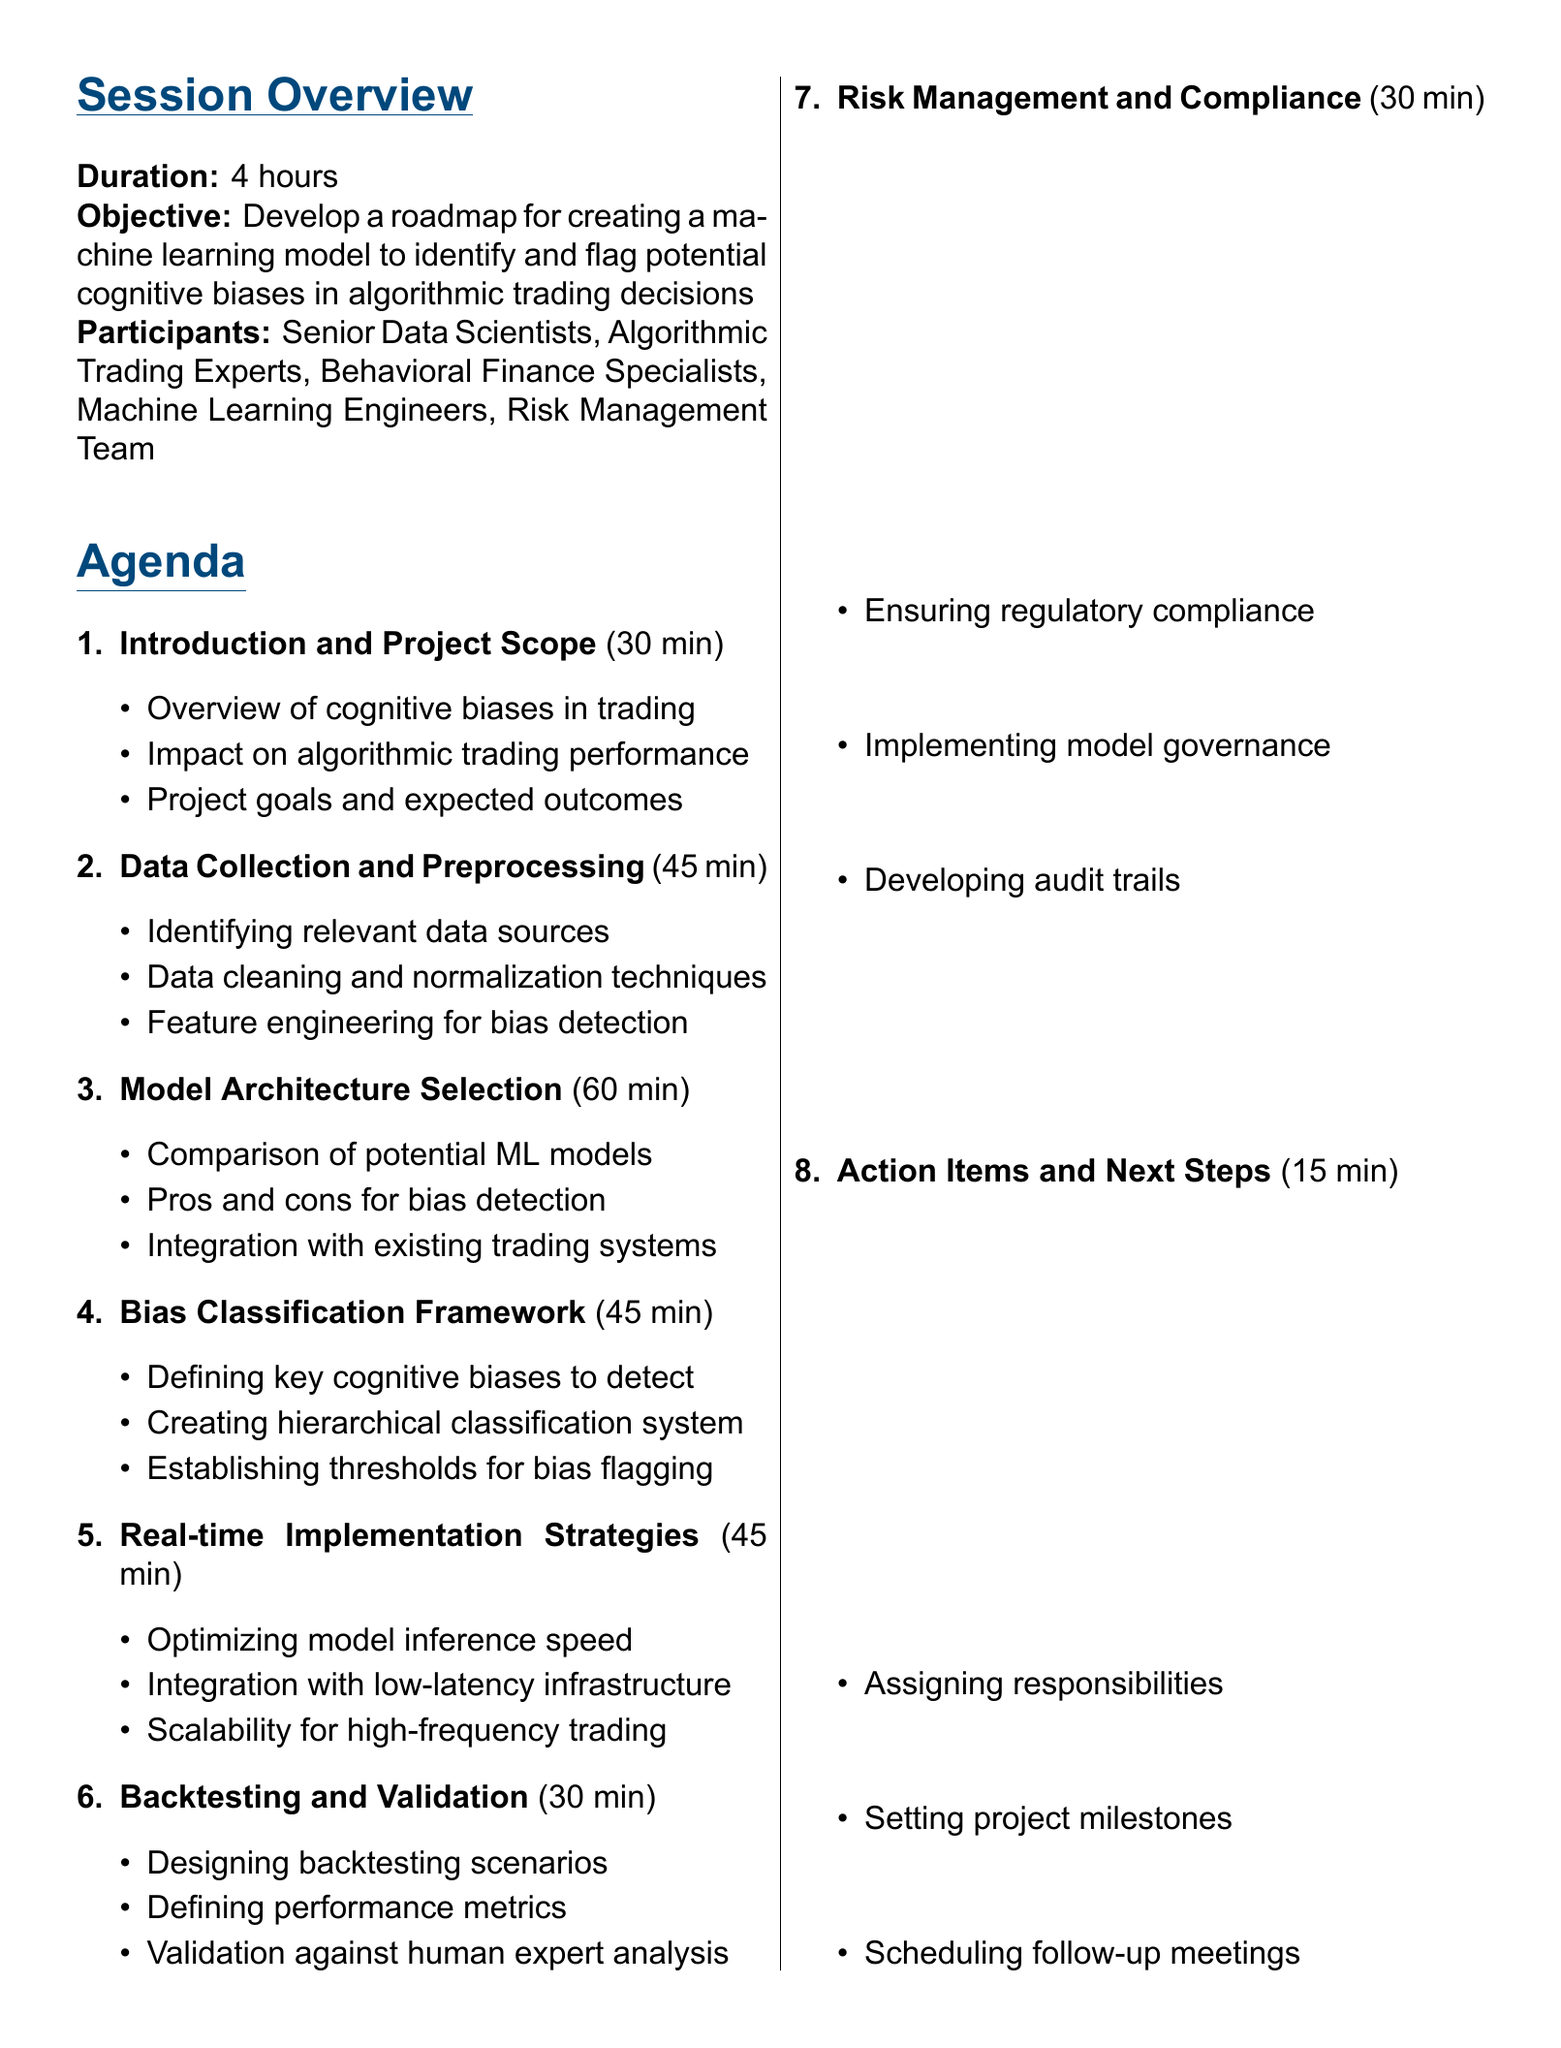what is the duration of the planning session? The duration is specified in the session overview section of the document.
Answer: 4 hours who are the participants involved in the session? The participants are listed in the session overview section of the document.
Answer: Senior Data Scientists, Algorithmic Trading Experts, Behavioral Finance Specialists, Machine Learning Engineers, Risk Management Team what is one of the expected outcomes of the session? Expected outcomes are outlined in the last section of the document, detailing what the session aims to achieve.
Answer: Detailed project plan for ML model development how long is allocated for model architecture selection? The duration for this agenda item is mentioned in the agenda section of the document.
Answer: 60 minutes which cognitive bias is mentioned as an example in the agenda? Bias classification details are included in the relevant session of the agenda.
Answer: Confirmation bias what is one resource needed for the model development? Resources needed for the project are specified in a dedicated section of the document.
Answer: Access to historical trading data what is the main objective of this planning session? The objective is stated clearly in the session overview section of the document.
Answer: Develop a roadmap for creating a machine learning model what is the time allocated for the action items and next steps? The duration for this agenda item can be found in the agenda section of the document.
Answer: 15 minutes 